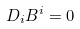<formula> <loc_0><loc_0><loc_500><loc_500>D _ { i } B ^ { i } = 0</formula> 